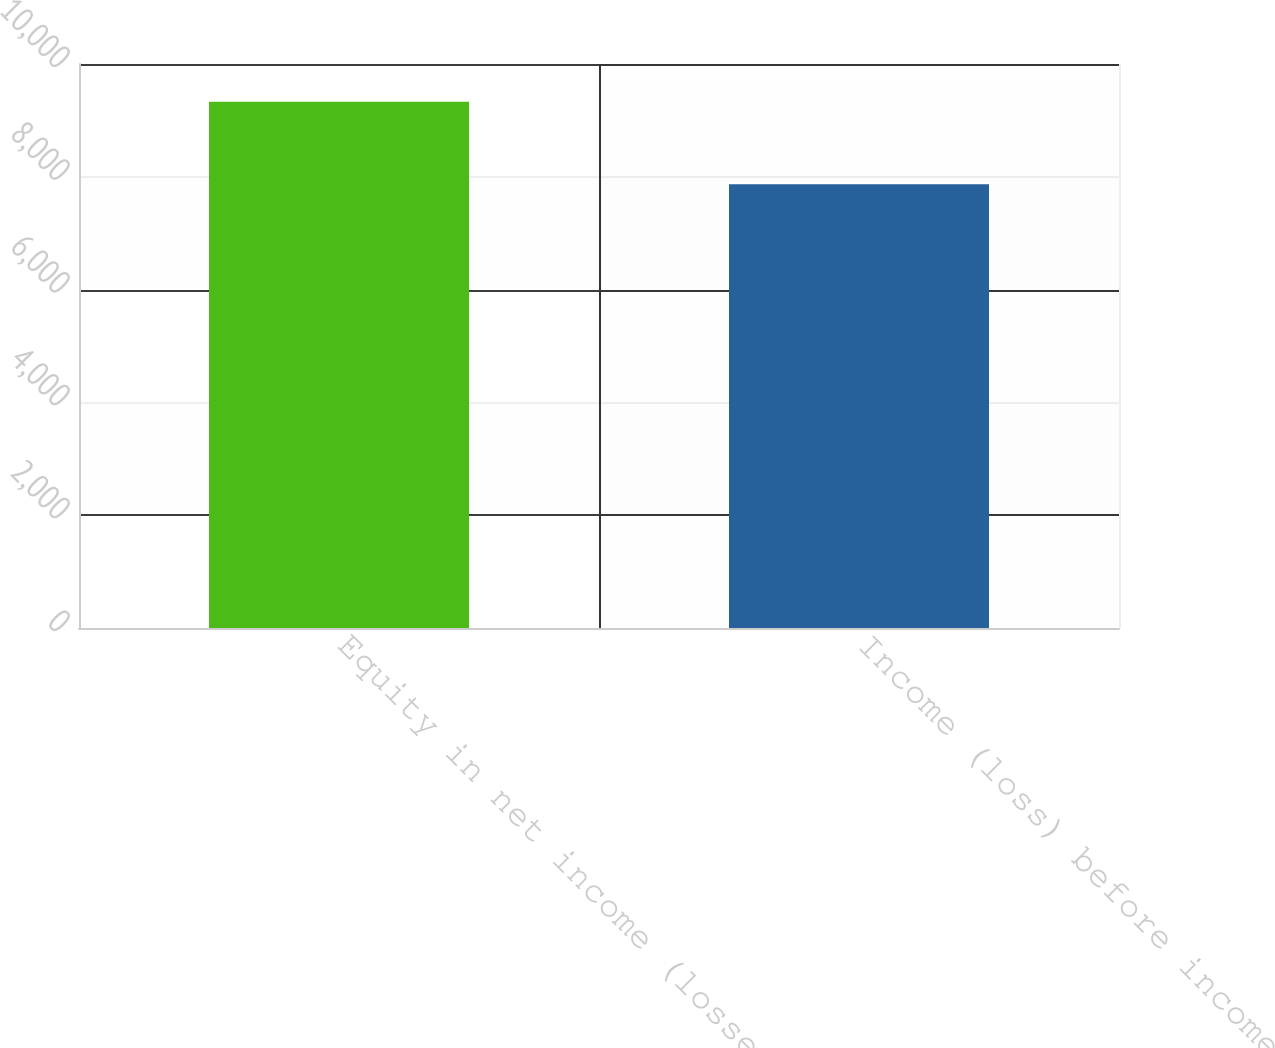<chart> <loc_0><loc_0><loc_500><loc_500><bar_chart><fcel>Equity in net income (losses)<fcel>Income (loss) before income<nl><fcel>9330<fcel>7868<nl></chart> 